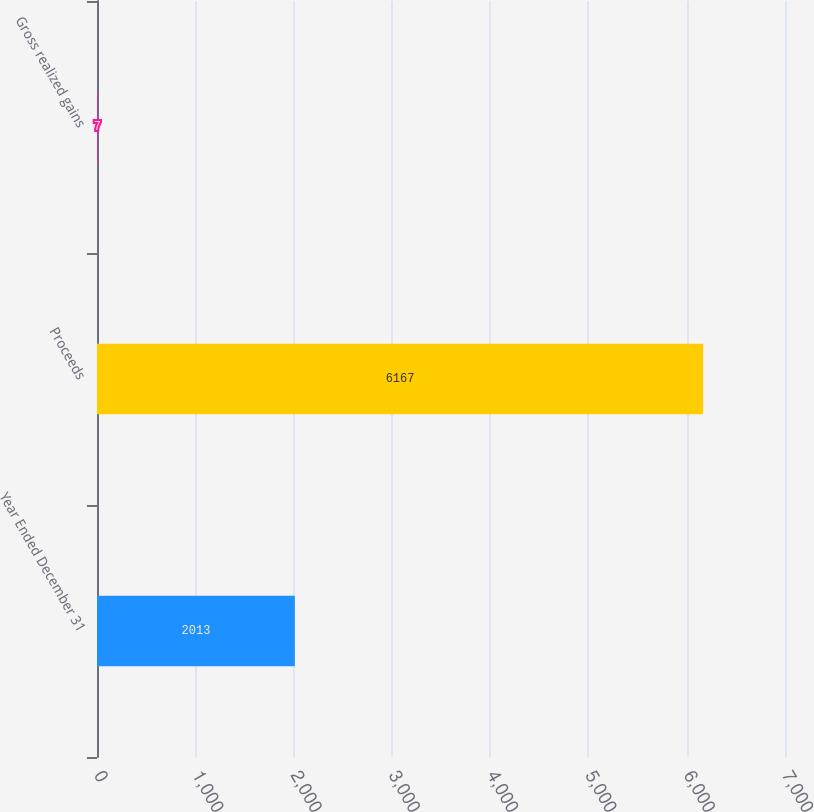Convert chart. <chart><loc_0><loc_0><loc_500><loc_500><bar_chart><fcel>Year Ended December 31<fcel>Proceeds<fcel>Gross realized gains<nl><fcel>2013<fcel>6167<fcel>7<nl></chart> 